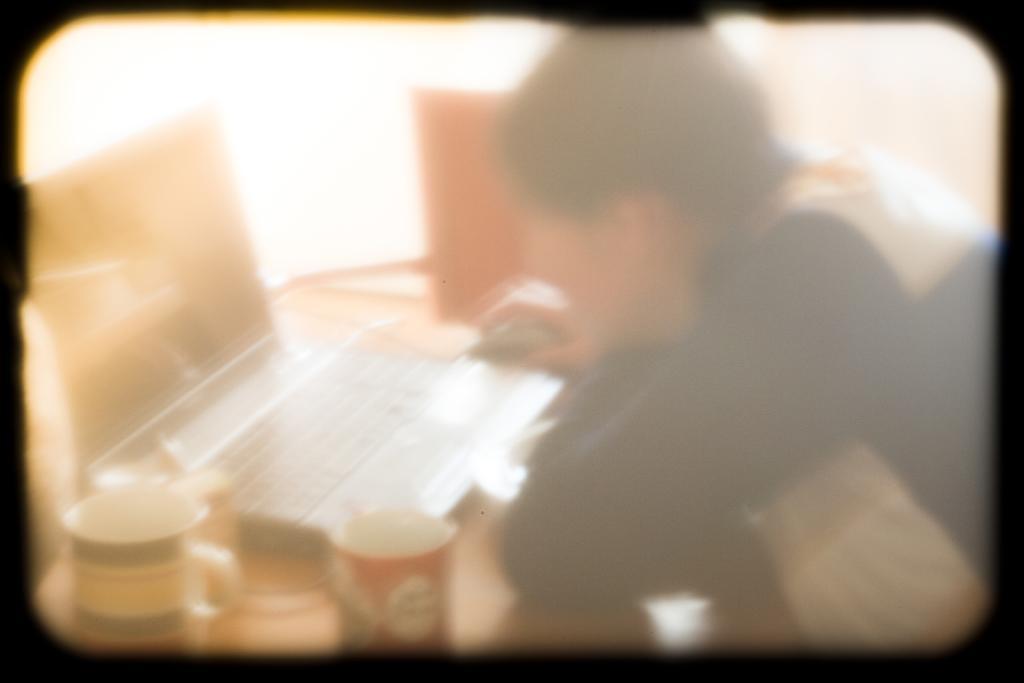Describe this image in one or two sentences. In this image I can see the blurry picture in which I can see a person sitting in front of a table and on the table I can see few cups, a laptop, a mouse and few other objects. 